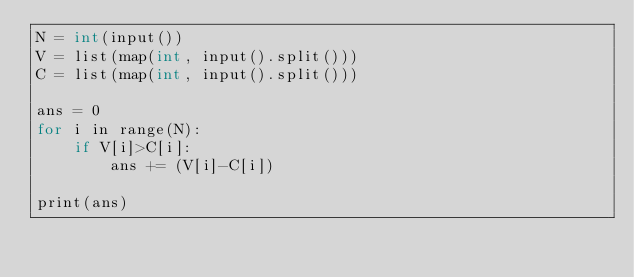<code> <loc_0><loc_0><loc_500><loc_500><_C++_>N = int(input())
V = list(map(int, input().split())) 
C = list(map(int, input().split())) 

ans = 0
for i in range(N):
    if V[i]>C[i]:
        ans += (V[i]-C[i])

print(ans)</code> 